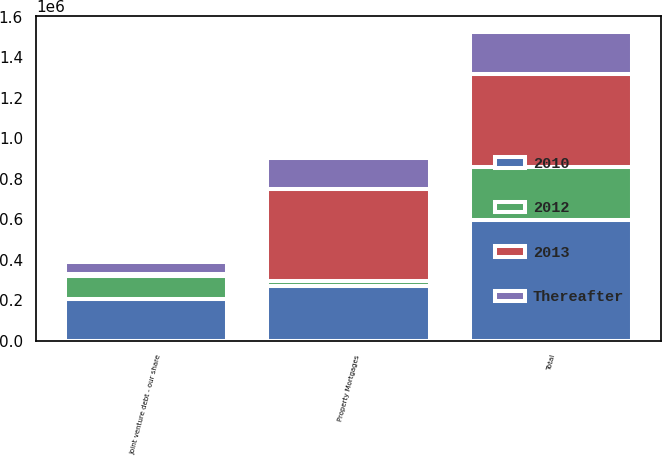Convert chart. <chart><loc_0><loc_0><loc_500><loc_500><stacked_bar_chart><ecel><fcel>Property Mortgages<fcel>Joint venture debt - our share<fcel>Total<nl><fcel>2012<fcel>28557<fcel>115130<fcel>258508<nl><fcel>2010<fcel>269185<fcel>206951<fcel>599743<nl><fcel>Thereafter<fcel>149975<fcel>60759<fcel>206951<nl><fcel>2013<fcel>454396<fcel>6684<fcel>461080<nl></chart> 